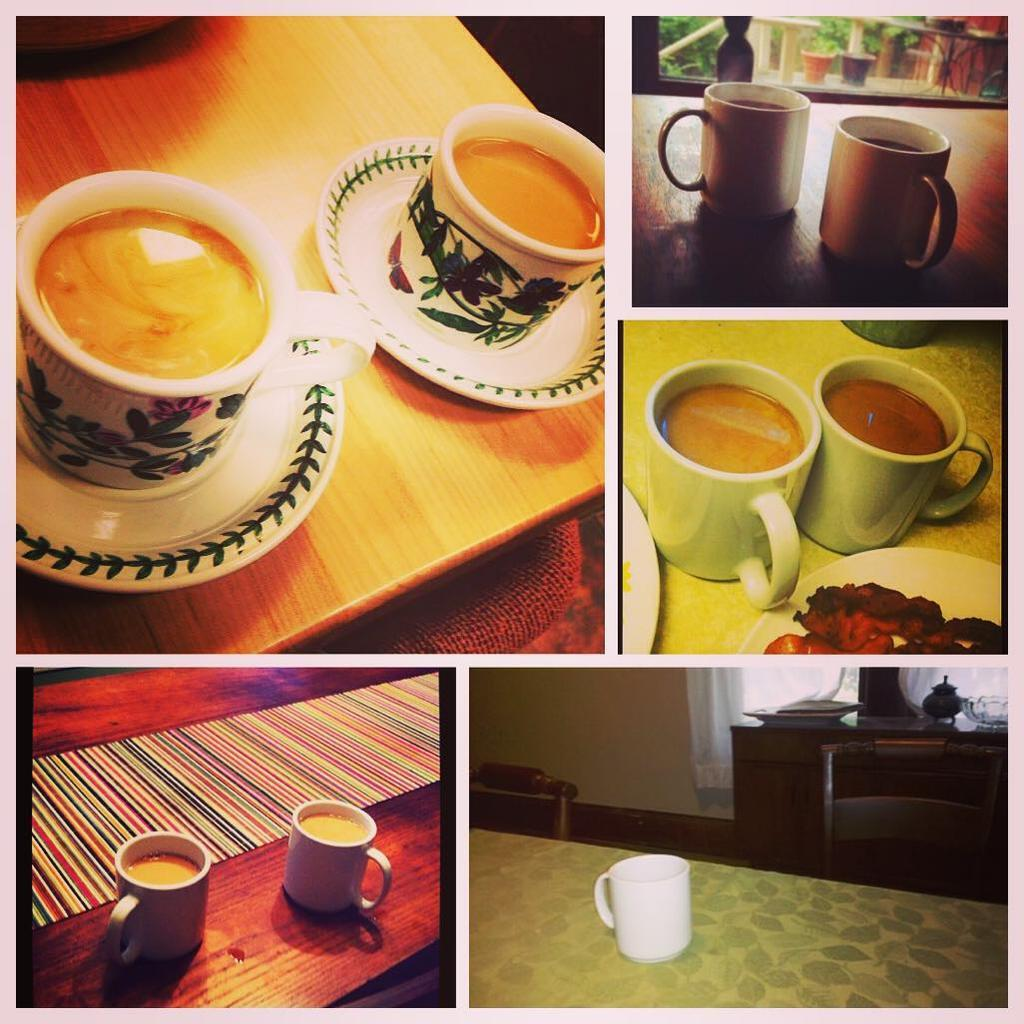What type of photo is in the image? There is a collage photo in the image. What objects are included in the collage photo? The collage photo contains cups and plates. What type of furniture is visible in the image? There are tables visible in the image. What can be inferred about the setting from the presence of food? There is food present in the image, which suggests that it might be a dining or gathering area. What is the weight of the bone visible in the image? There is no bone present in the image. 